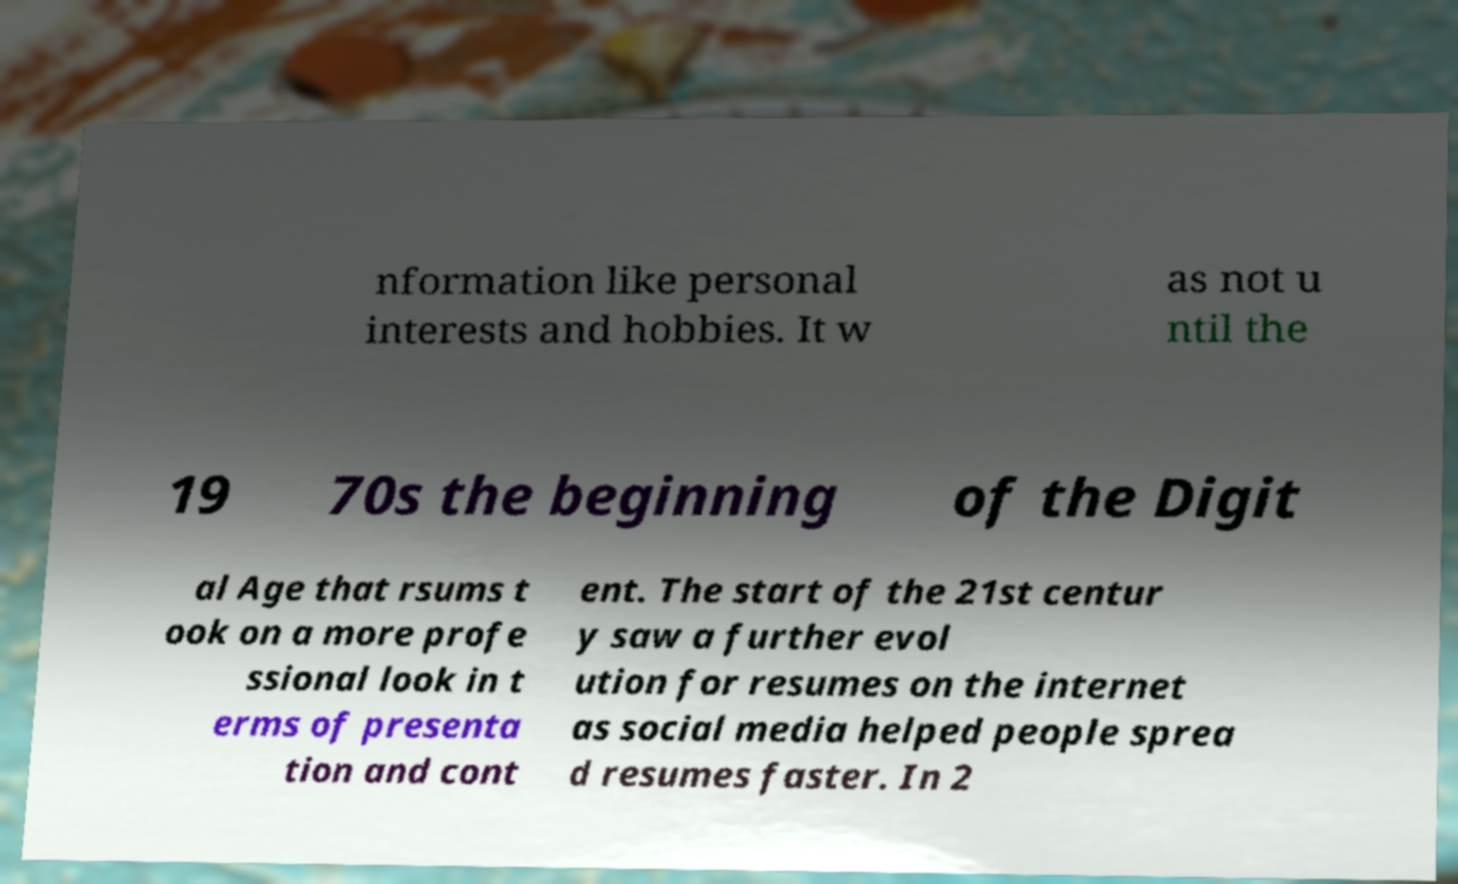I need the written content from this picture converted into text. Can you do that? nformation like personal interests and hobbies. It w as not u ntil the 19 70s the beginning of the Digit al Age that rsums t ook on a more profe ssional look in t erms of presenta tion and cont ent. The start of the 21st centur y saw a further evol ution for resumes on the internet as social media helped people sprea d resumes faster. In 2 